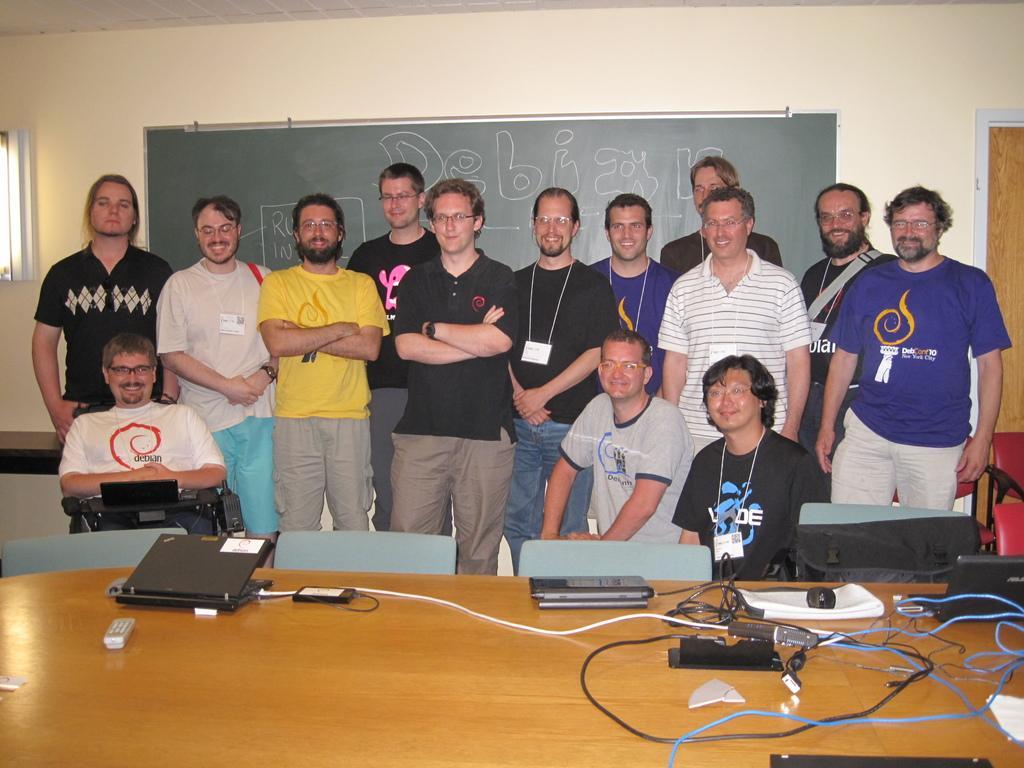Could you give a brief overview of what you see in this image? In the image there is a table in the foreground and on the table there are laptops, wires and other gadgets. Behind the table there are empty chairs and there are few people standing in front of the board and behind the board there is a wall. 